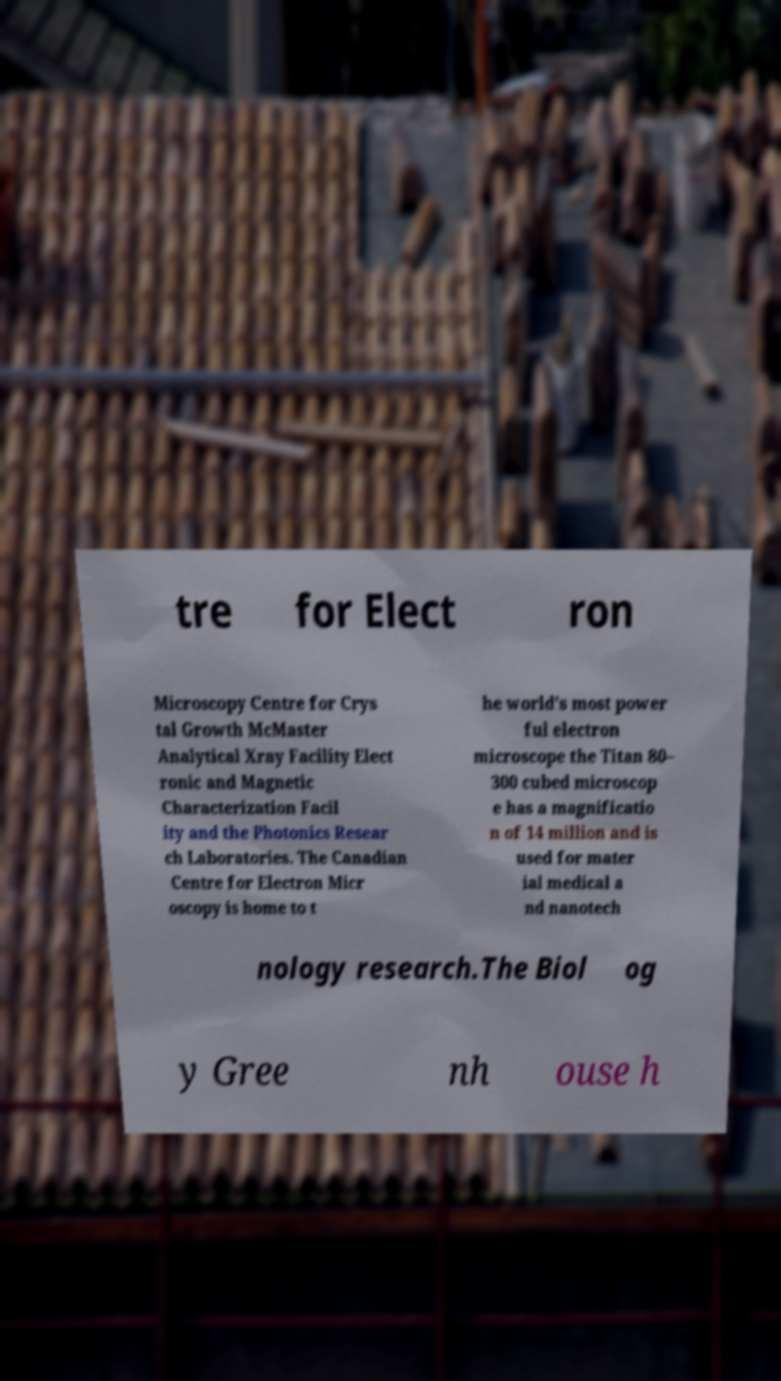Can you read and provide the text displayed in the image?This photo seems to have some interesting text. Can you extract and type it out for me? tre for Elect ron Microscopy Centre for Crys tal Growth McMaster Analytical Xray Facility Elect ronic and Magnetic Characterization Facil ity and the Photonics Resear ch Laboratories. The Canadian Centre for Electron Micr oscopy is home to t he world's most power ful electron microscope the Titan 80– 300 cubed microscop e has a magnificatio n of 14 million and is used for mater ial medical a nd nanotech nology research.The Biol og y Gree nh ouse h 